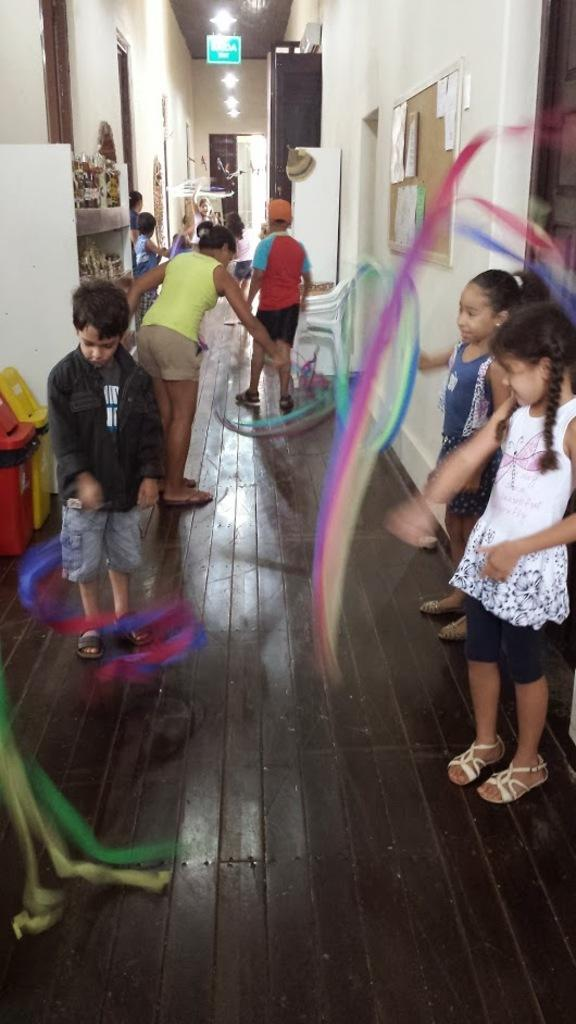Who is present in the image? There are kids and a lady in the image. What are they doing in the image? They are standing on the floor. What can be seen on the wall in the image? There is a wall with a notice board in the image. What is on the shelf in the image? There is a shelf with some things in the image. What type of hose is being used by the kids in the image? There is no hose present in the image. What kind of care is the lady providing to the kids in the image? The image does not show any specific care being provided by the lady to the kids. 